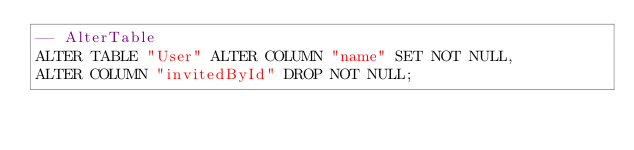<code> <loc_0><loc_0><loc_500><loc_500><_SQL_>-- AlterTable
ALTER TABLE "User" ALTER COLUMN "name" SET NOT NULL,
ALTER COLUMN "invitedById" DROP NOT NULL;
</code> 